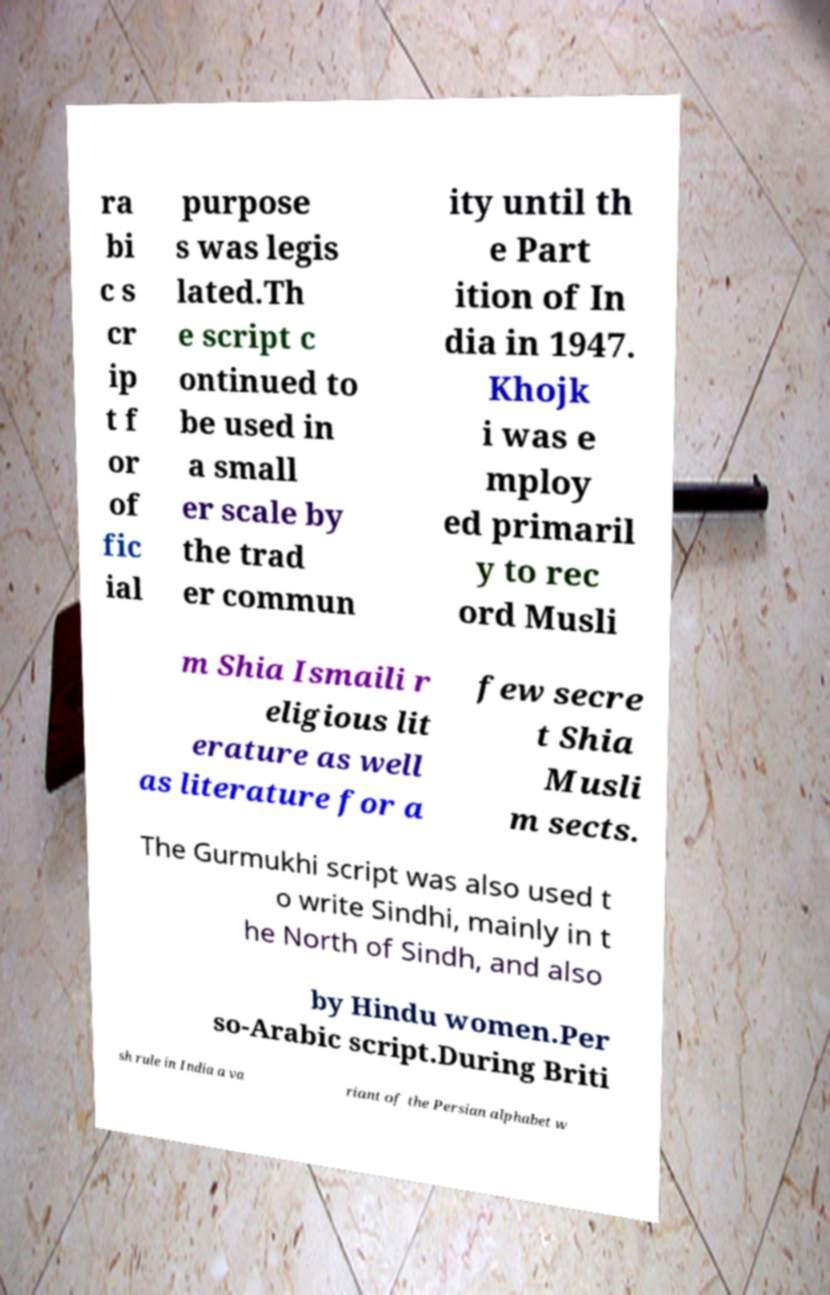For documentation purposes, I need the text within this image transcribed. Could you provide that? ra bi c s cr ip t f or of fic ial purpose s was legis lated.Th e script c ontinued to be used in a small er scale by the trad er commun ity until th e Part ition of In dia in 1947. Khojk i was e mploy ed primaril y to rec ord Musli m Shia Ismaili r eligious lit erature as well as literature for a few secre t Shia Musli m sects. The Gurmukhi script was also used t o write Sindhi, mainly in t he North of Sindh, and also by Hindu women.Per so-Arabic script.During Briti sh rule in India a va riant of the Persian alphabet w 